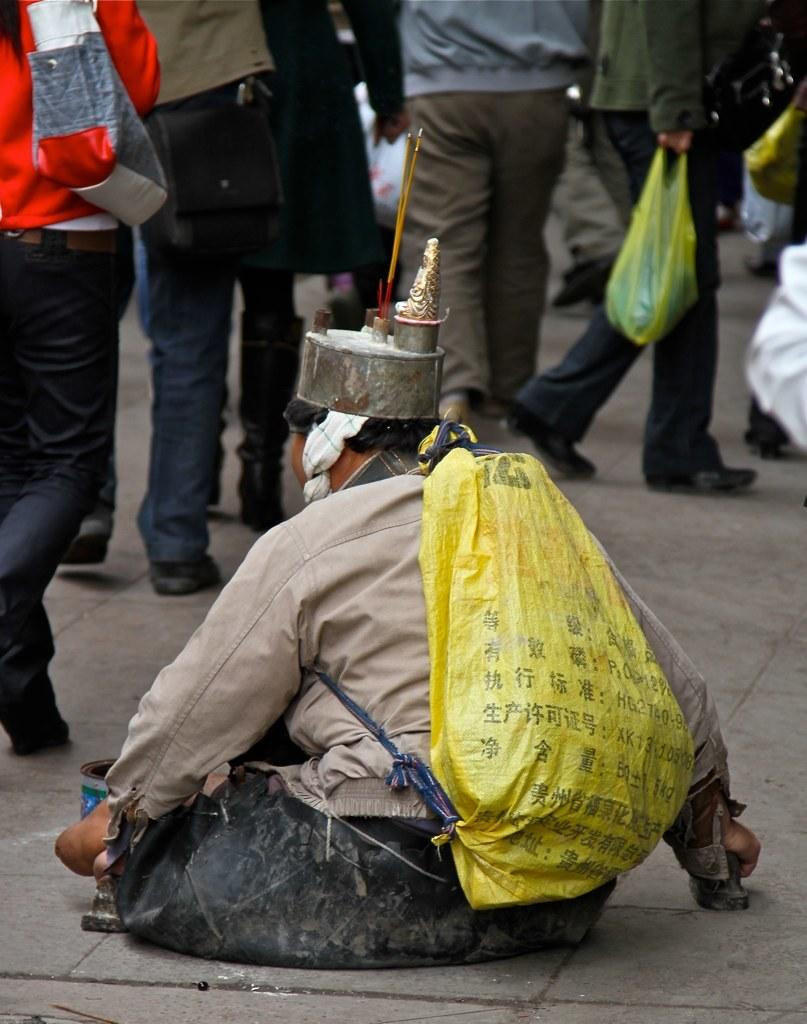What is the main subject of the image? The main subject of the image is a group of people. What are some of the people in the group doing? Some people in the group are carrying bags. Can you tell me how many boats are in the harbor in the image? There is no harbor or boats present in the image; it features a group of people. What type of bubble is floating near the history in the image? There is no bubble or history present in the image; it features a group of people. 